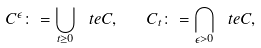<formula> <loc_0><loc_0><loc_500><loc_500>C ^ { \epsilon } \colon = \bigcup _ { t \geq 0 } \ t e { C } , \quad C _ { t } \colon = \bigcap _ { \epsilon > 0 } \ t e { C } ,</formula> 